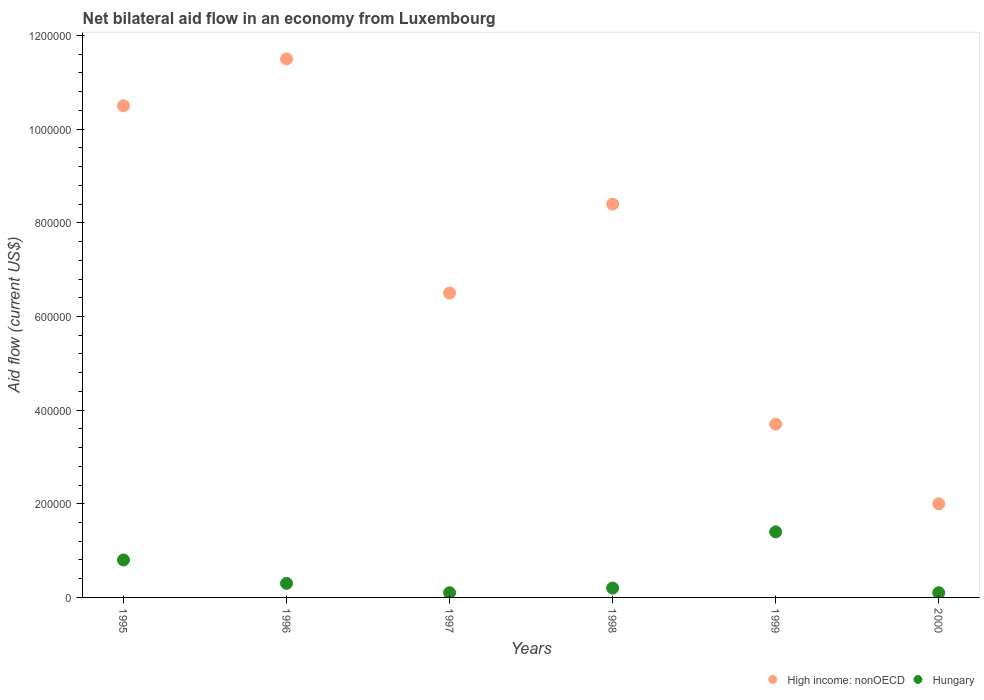How many different coloured dotlines are there?
Provide a short and direct response. 2. Is the number of dotlines equal to the number of legend labels?
Ensure brevity in your answer.  Yes. What is the net bilateral aid flow in High income: nonOECD in 1996?
Offer a very short reply. 1.15e+06. Across all years, what is the maximum net bilateral aid flow in High income: nonOECD?
Give a very brief answer. 1.15e+06. In which year was the net bilateral aid flow in Hungary maximum?
Provide a short and direct response. 1999. In which year was the net bilateral aid flow in High income: nonOECD minimum?
Keep it short and to the point. 2000. What is the total net bilateral aid flow in High income: nonOECD in the graph?
Keep it short and to the point. 4.26e+06. What is the difference between the net bilateral aid flow in High income: nonOECD in 1995 and that in 1998?
Offer a terse response. 2.10e+05. What is the difference between the net bilateral aid flow in High income: nonOECD in 1998 and the net bilateral aid flow in Hungary in 1997?
Your response must be concise. 8.30e+05. What is the average net bilateral aid flow in Hungary per year?
Your answer should be compact. 4.83e+04. In the year 1995, what is the difference between the net bilateral aid flow in High income: nonOECD and net bilateral aid flow in Hungary?
Provide a succinct answer. 9.70e+05. What is the ratio of the net bilateral aid flow in Hungary in 1998 to that in 1999?
Give a very brief answer. 0.14. Is the difference between the net bilateral aid flow in High income: nonOECD in 1998 and 2000 greater than the difference between the net bilateral aid flow in Hungary in 1998 and 2000?
Your answer should be very brief. Yes. What is the difference between the highest and the second highest net bilateral aid flow in High income: nonOECD?
Provide a succinct answer. 1.00e+05. What is the difference between the highest and the lowest net bilateral aid flow in High income: nonOECD?
Keep it short and to the point. 9.50e+05. Is the sum of the net bilateral aid flow in High income: nonOECD in 1996 and 1999 greater than the maximum net bilateral aid flow in Hungary across all years?
Your answer should be very brief. Yes. Is the net bilateral aid flow in High income: nonOECD strictly less than the net bilateral aid flow in Hungary over the years?
Keep it short and to the point. No. Are the values on the major ticks of Y-axis written in scientific E-notation?
Your answer should be compact. No. Does the graph contain any zero values?
Your response must be concise. No. What is the title of the graph?
Ensure brevity in your answer.  Net bilateral aid flow in an economy from Luxembourg. Does "Mauritania" appear as one of the legend labels in the graph?
Offer a very short reply. No. What is the label or title of the X-axis?
Give a very brief answer. Years. What is the Aid flow (current US$) in High income: nonOECD in 1995?
Offer a very short reply. 1.05e+06. What is the Aid flow (current US$) of Hungary in 1995?
Your response must be concise. 8.00e+04. What is the Aid flow (current US$) of High income: nonOECD in 1996?
Your answer should be very brief. 1.15e+06. What is the Aid flow (current US$) of High income: nonOECD in 1997?
Make the answer very short. 6.50e+05. What is the Aid flow (current US$) of High income: nonOECD in 1998?
Keep it short and to the point. 8.40e+05. What is the Aid flow (current US$) in Hungary in 1998?
Your answer should be compact. 2.00e+04. What is the Aid flow (current US$) in High income: nonOECD in 1999?
Ensure brevity in your answer.  3.70e+05. What is the Aid flow (current US$) in Hungary in 1999?
Your answer should be very brief. 1.40e+05. Across all years, what is the maximum Aid flow (current US$) of High income: nonOECD?
Offer a terse response. 1.15e+06. Across all years, what is the maximum Aid flow (current US$) in Hungary?
Offer a very short reply. 1.40e+05. What is the total Aid flow (current US$) of High income: nonOECD in the graph?
Your response must be concise. 4.26e+06. What is the total Aid flow (current US$) in Hungary in the graph?
Ensure brevity in your answer.  2.90e+05. What is the difference between the Aid flow (current US$) of Hungary in 1995 and that in 1996?
Give a very brief answer. 5.00e+04. What is the difference between the Aid flow (current US$) in Hungary in 1995 and that in 1997?
Your response must be concise. 7.00e+04. What is the difference between the Aid flow (current US$) of Hungary in 1995 and that in 1998?
Your response must be concise. 6.00e+04. What is the difference between the Aid flow (current US$) of High income: nonOECD in 1995 and that in 1999?
Make the answer very short. 6.80e+05. What is the difference between the Aid flow (current US$) in High income: nonOECD in 1995 and that in 2000?
Keep it short and to the point. 8.50e+05. What is the difference between the Aid flow (current US$) in Hungary in 1995 and that in 2000?
Make the answer very short. 7.00e+04. What is the difference between the Aid flow (current US$) in High income: nonOECD in 1996 and that in 1998?
Provide a short and direct response. 3.10e+05. What is the difference between the Aid flow (current US$) in High income: nonOECD in 1996 and that in 1999?
Provide a succinct answer. 7.80e+05. What is the difference between the Aid flow (current US$) of Hungary in 1996 and that in 1999?
Provide a succinct answer. -1.10e+05. What is the difference between the Aid flow (current US$) in High income: nonOECD in 1996 and that in 2000?
Make the answer very short. 9.50e+05. What is the difference between the Aid flow (current US$) in High income: nonOECD in 1997 and that in 1998?
Provide a succinct answer. -1.90e+05. What is the difference between the Aid flow (current US$) of High income: nonOECD in 1997 and that in 2000?
Your answer should be very brief. 4.50e+05. What is the difference between the Aid flow (current US$) of Hungary in 1997 and that in 2000?
Offer a very short reply. 0. What is the difference between the Aid flow (current US$) in High income: nonOECD in 1998 and that in 2000?
Your answer should be compact. 6.40e+05. What is the difference between the Aid flow (current US$) of High income: nonOECD in 1999 and that in 2000?
Give a very brief answer. 1.70e+05. What is the difference between the Aid flow (current US$) in Hungary in 1999 and that in 2000?
Ensure brevity in your answer.  1.30e+05. What is the difference between the Aid flow (current US$) of High income: nonOECD in 1995 and the Aid flow (current US$) of Hungary in 1996?
Provide a succinct answer. 1.02e+06. What is the difference between the Aid flow (current US$) of High income: nonOECD in 1995 and the Aid flow (current US$) of Hungary in 1997?
Make the answer very short. 1.04e+06. What is the difference between the Aid flow (current US$) in High income: nonOECD in 1995 and the Aid flow (current US$) in Hungary in 1998?
Provide a succinct answer. 1.03e+06. What is the difference between the Aid flow (current US$) in High income: nonOECD in 1995 and the Aid flow (current US$) in Hungary in 1999?
Keep it short and to the point. 9.10e+05. What is the difference between the Aid flow (current US$) in High income: nonOECD in 1995 and the Aid flow (current US$) in Hungary in 2000?
Ensure brevity in your answer.  1.04e+06. What is the difference between the Aid flow (current US$) of High income: nonOECD in 1996 and the Aid flow (current US$) of Hungary in 1997?
Your answer should be compact. 1.14e+06. What is the difference between the Aid flow (current US$) of High income: nonOECD in 1996 and the Aid flow (current US$) of Hungary in 1998?
Keep it short and to the point. 1.13e+06. What is the difference between the Aid flow (current US$) in High income: nonOECD in 1996 and the Aid flow (current US$) in Hungary in 1999?
Your response must be concise. 1.01e+06. What is the difference between the Aid flow (current US$) of High income: nonOECD in 1996 and the Aid flow (current US$) of Hungary in 2000?
Give a very brief answer. 1.14e+06. What is the difference between the Aid flow (current US$) of High income: nonOECD in 1997 and the Aid flow (current US$) of Hungary in 1998?
Offer a terse response. 6.30e+05. What is the difference between the Aid flow (current US$) of High income: nonOECD in 1997 and the Aid flow (current US$) of Hungary in 1999?
Your answer should be compact. 5.10e+05. What is the difference between the Aid flow (current US$) of High income: nonOECD in 1997 and the Aid flow (current US$) of Hungary in 2000?
Ensure brevity in your answer.  6.40e+05. What is the difference between the Aid flow (current US$) in High income: nonOECD in 1998 and the Aid flow (current US$) in Hungary in 2000?
Provide a succinct answer. 8.30e+05. What is the average Aid flow (current US$) in High income: nonOECD per year?
Your answer should be very brief. 7.10e+05. What is the average Aid flow (current US$) in Hungary per year?
Provide a short and direct response. 4.83e+04. In the year 1995, what is the difference between the Aid flow (current US$) of High income: nonOECD and Aid flow (current US$) of Hungary?
Give a very brief answer. 9.70e+05. In the year 1996, what is the difference between the Aid flow (current US$) of High income: nonOECD and Aid flow (current US$) of Hungary?
Give a very brief answer. 1.12e+06. In the year 1997, what is the difference between the Aid flow (current US$) of High income: nonOECD and Aid flow (current US$) of Hungary?
Keep it short and to the point. 6.40e+05. In the year 1998, what is the difference between the Aid flow (current US$) of High income: nonOECD and Aid flow (current US$) of Hungary?
Your answer should be compact. 8.20e+05. In the year 2000, what is the difference between the Aid flow (current US$) in High income: nonOECD and Aid flow (current US$) in Hungary?
Make the answer very short. 1.90e+05. What is the ratio of the Aid flow (current US$) of High income: nonOECD in 1995 to that in 1996?
Offer a terse response. 0.91. What is the ratio of the Aid flow (current US$) of Hungary in 1995 to that in 1996?
Offer a very short reply. 2.67. What is the ratio of the Aid flow (current US$) of High income: nonOECD in 1995 to that in 1997?
Make the answer very short. 1.62. What is the ratio of the Aid flow (current US$) of Hungary in 1995 to that in 1997?
Make the answer very short. 8. What is the ratio of the Aid flow (current US$) of Hungary in 1995 to that in 1998?
Keep it short and to the point. 4. What is the ratio of the Aid flow (current US$) in High income: nonOECD in 1995 to that in 1999?
Make the answer very short. 2.84. What is the ratio of the Aid flow (current US$) of Hungary in 1995 to that in 1999?
Keep it short and to the point. 0.57. What is the ratio of the Aid flow (current US$) in High income: nonOECD in 1995 to that in 2000?
Provide a succinct answer. 5.25. What is the ratio of the Aid flow (current US$) of Hungary in 1995 to that in 2000?
Keep it short and to the point. 8. What is the ratio of the Aid flow (current US$) in High income: nonOECD in 1996 to that in 1997?
Keep it short and to the point. 1.77. What is the ratio of the Aid flow (current US$) of Hungary in 1996 to that in 1997?
Provide a short and direct response. 3. What is the ratio of the Aid flow (current US$) of High income: nonOECD in 1996 to that in 1998?
Your answer should be very brief. 1.37. What is the ratio of the Aid flow (current US$) of Hungary in 1996 to that in 1998?
Give a very brief answer. 1.5. What is the ratio of the Aid flow (current US$) of High income: nonOECD in 1996 to that in 1999?
Offer a very short reply. 3.11. What is the ratio of the Aid flow (current US$) of Hungary in 1996 to that in 1999?
Provide a succinct answer. 0.21. What is the ratio of the Aid flow (current US$) in High income: nonOECD in 1996 to that in 2000?
Your answer should be compact. 5.75. What is the ratio of the Aid flow (current US$) in High income: nonOECD in 1997 to that in 1998?
Offer a terse response. 0.77. What is the ratio of the Aid flow (current US$) in High income: nonOECD in 1997 to that in 1999?
Give a very brief answer. 1.76. What is the ratio of the Aid flow (current US$) of Hungary in 1997 to that in 1999?
Your response must be concise. 0.07. What is the ratio of the Aid flow (current US$) in High income: nonOECD in 1998 to that in 1999?
Ensure brevity in your answer.  2.27. What is the ratio of the Aid flow (current US$) of Hungary in 1998 to that in 1999?
Provide a short and direct response. 0.14. What is the ratio of the Aid flow (current US$) of High income: nonOECD in 1998 to that in 2000?
Offer a very short reply. 4.2. What is the ratio of the Aid flow (current US$) in Hungary in 1998 to that in 2000?
Your response must be concise. 2. What is the ratio of the Aid flow (current US$) of High income: nonOECD in 1999 to that in 2000?
Give a very brief answer. 1.85. What is the difference between the highest and the second highest Aid flow (current US$) of High income: nonOECD?
Provide a short and direct response. 1.00e+05. What is the difference between the highest and the lowest Aid flow (current US$) in High income: nonOECD?
Your response must be concise. 9.50e+05. What is the difference between the highest and the lowest Aid flow (current US$) of Hungary?
Give a very brief answer. 1.30e+05. 